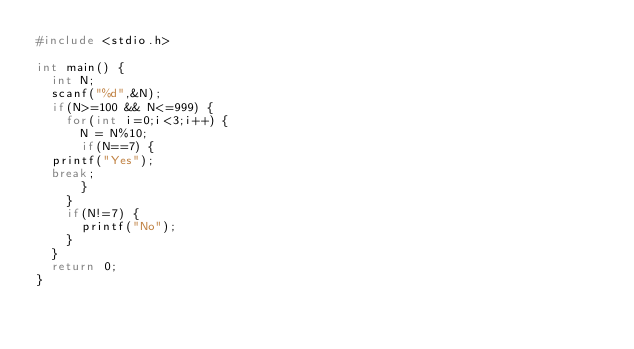Convert code to text. <code><loc_0><loc_0><loc_500><loc_500><_C_>#include <stdio.h>

int main() {
  int N;
  scanf("%d",&N);
  if(N>=100 && N<=999) {
    for(int i=0;i<3;i++) {
      N = N%10;
      if(N==7) {
	printf("Yes");
	break;
      }
    }
    if(N!=7) {
      printf("No");
    }
  }
  return 0;
}</code> 